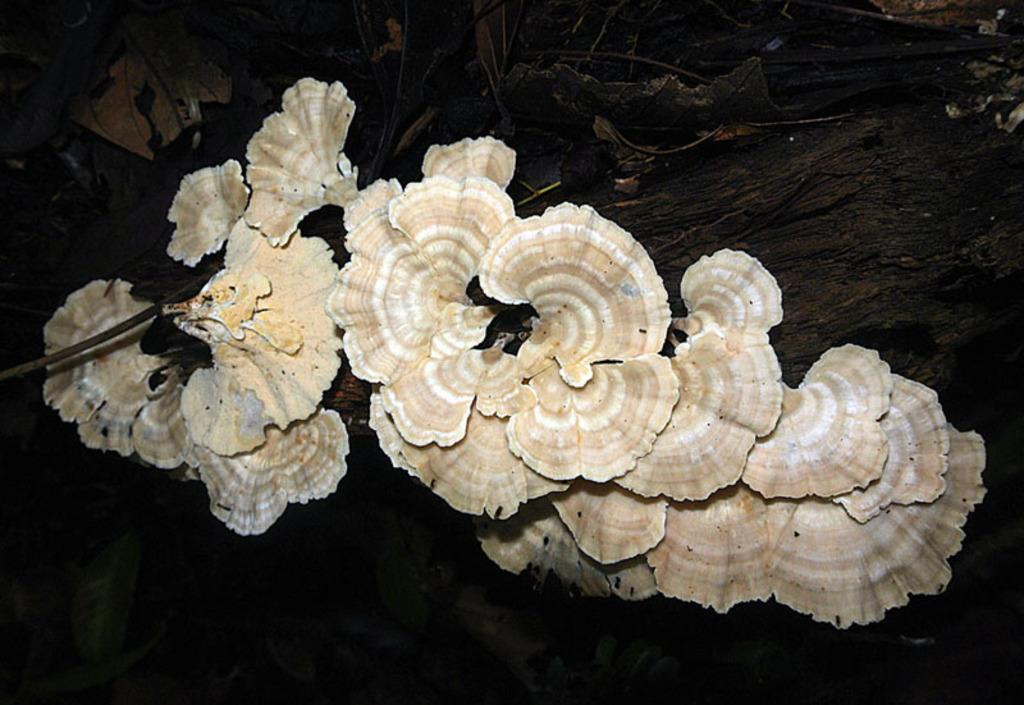Describe this image in one or two sentences. Here we can see fungus on a tree. In the background we can see leaves and the image is not clear. 